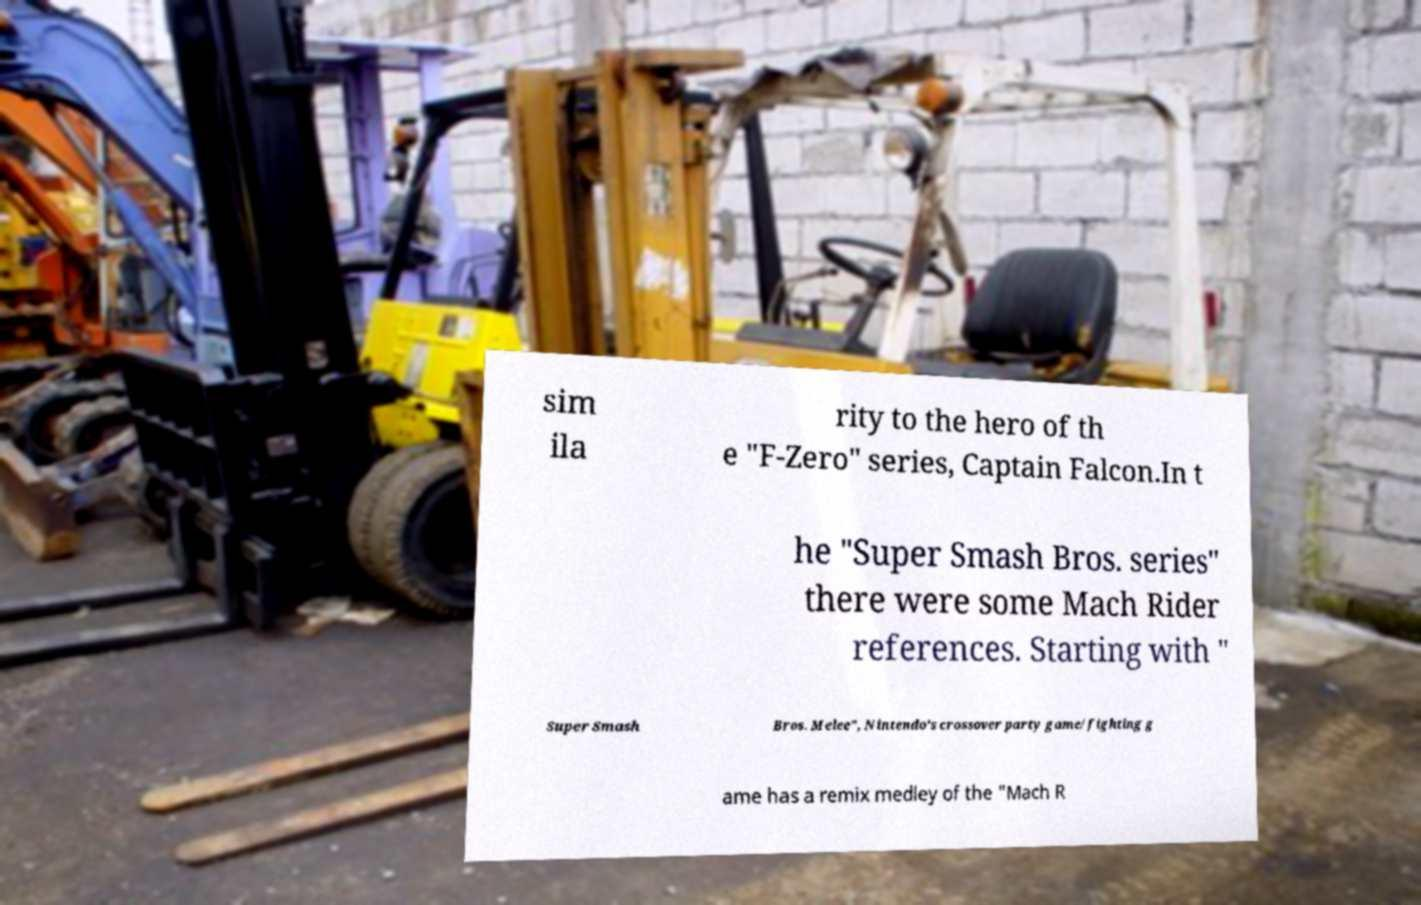There's text embedded in this image that I need extracted. Can you transcribe it verbatim? sim ila rity to the hero of th e "F-Zero" series, Captain Falcon.In t he "Super Smash Bros. series" there were some Mach Rider references. Starting with " Super Smash Bros. Melee", Nintendo's crossover party game/fighting g ame has a remix medley of the "Mach R 